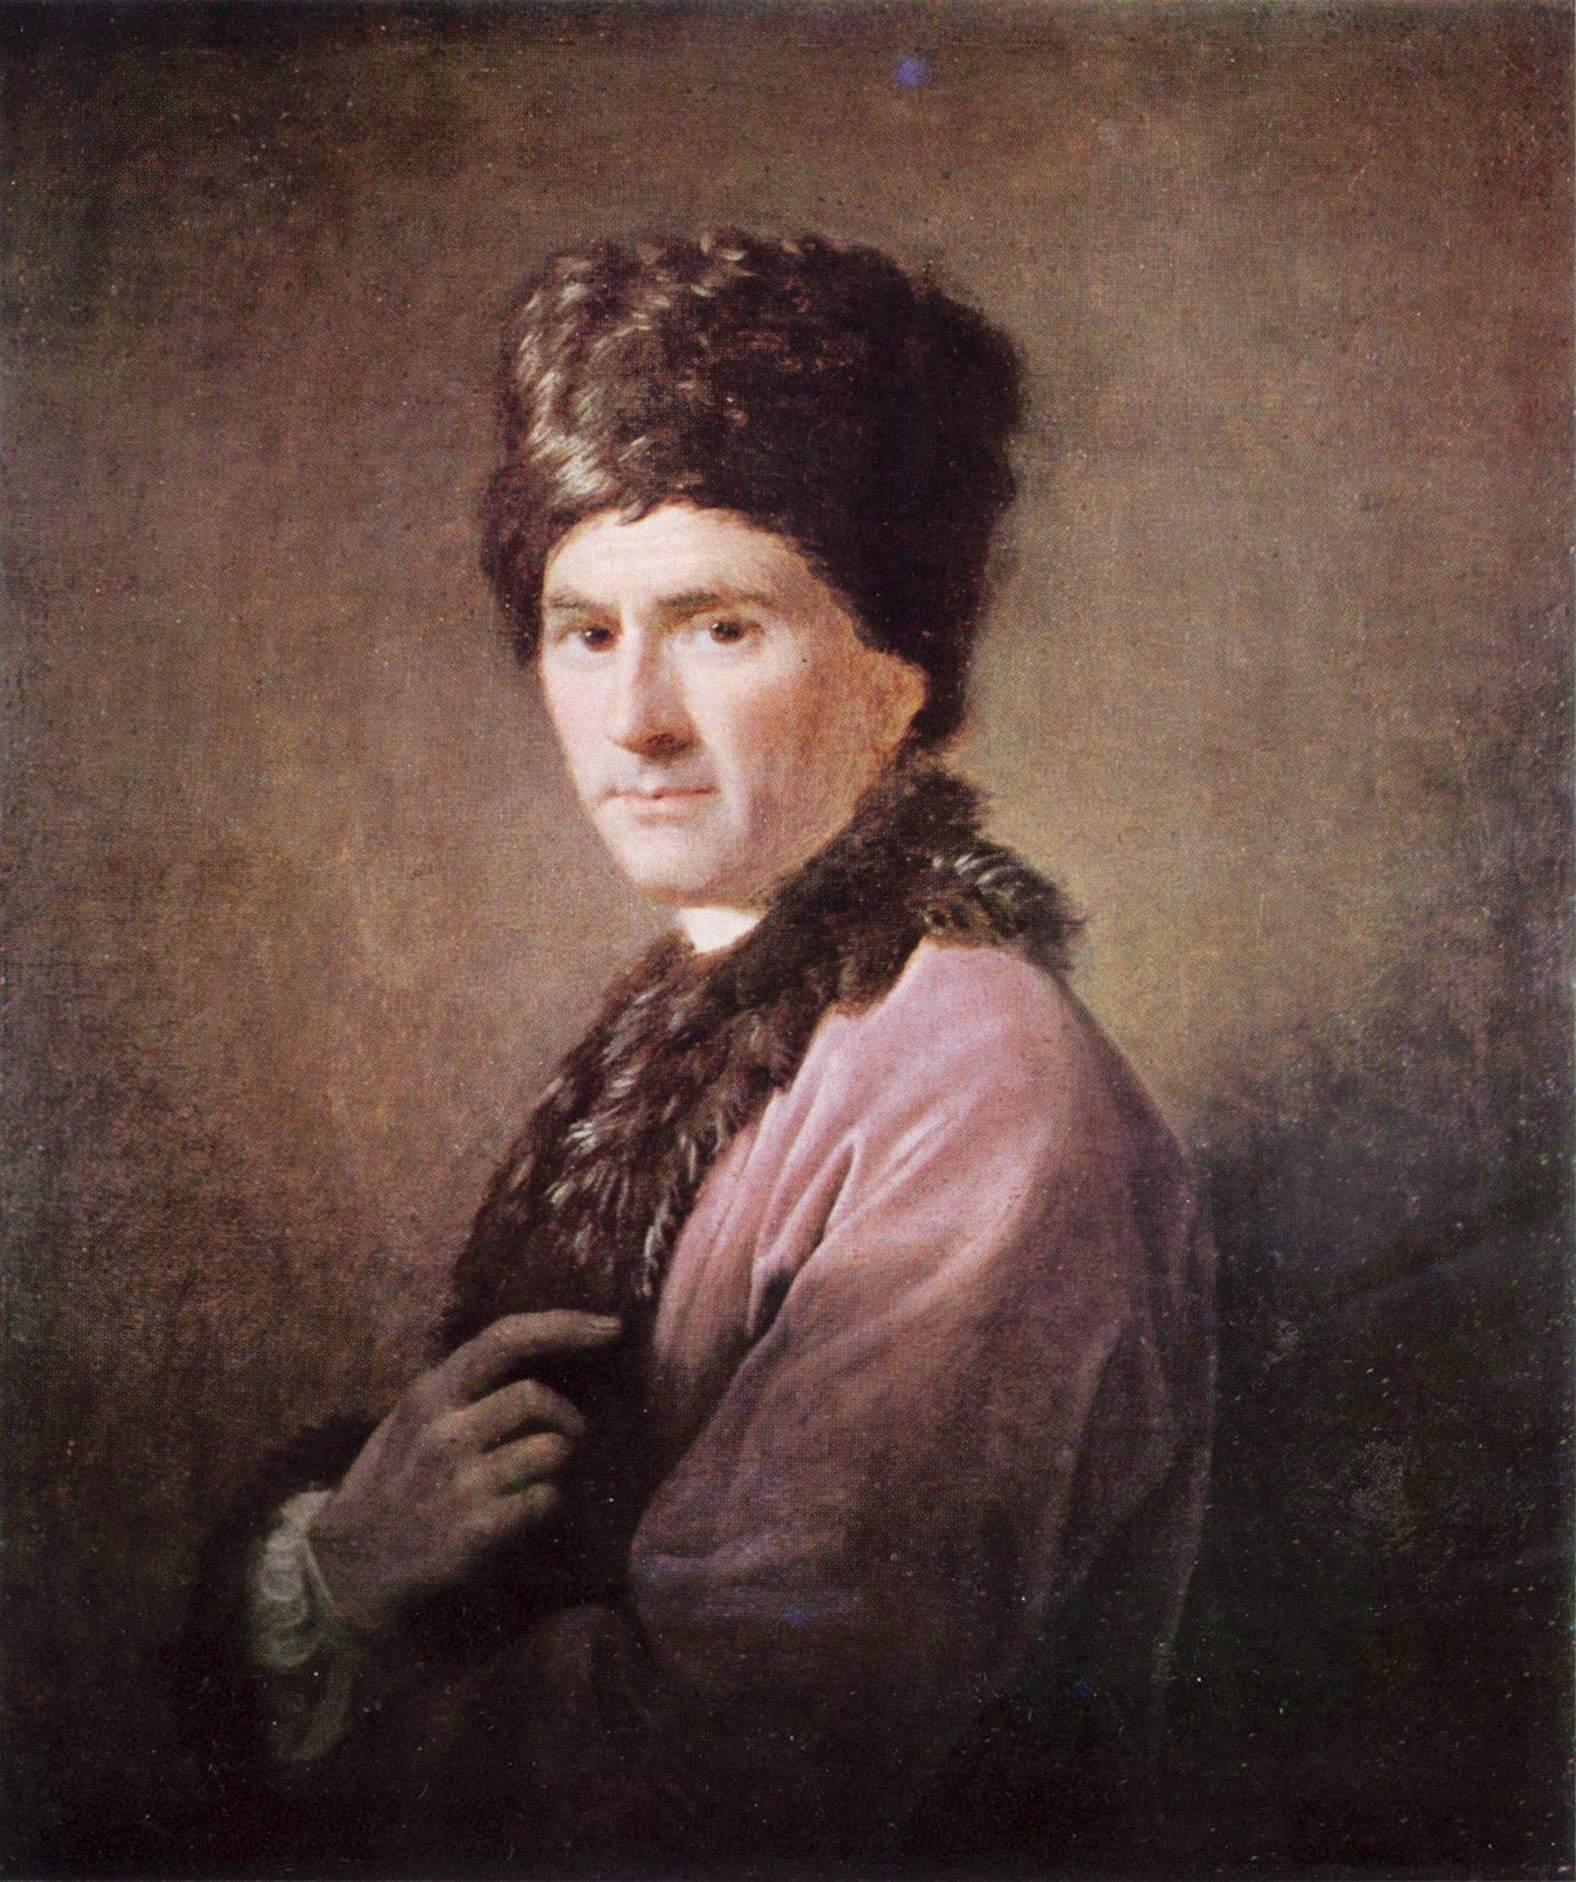Can you elaborate on the elements of the picture provided?
 The image portrays a young man, captured in a three-quarter view. He is adorned in a vibrant pink coat with a plush fur collar, and a large fur hat rests atop his head. The attire suggests a sense of opulence and luxury. The background is a stark contrast to the subject, painted in a dark brown color that accentuates the dramatic lighting falling on the man. The painting is executed in an oil on canvas style, a technique known for its depth and detail. It belongs to the Rococo art genre, renowned for its ornate and decorative style. The overall composition and the use of light and shadow bring a sense of depth and realism to the portrait. The man's gaze, directed towards something outside the frame, adds an element of intrigue to the artwork. 